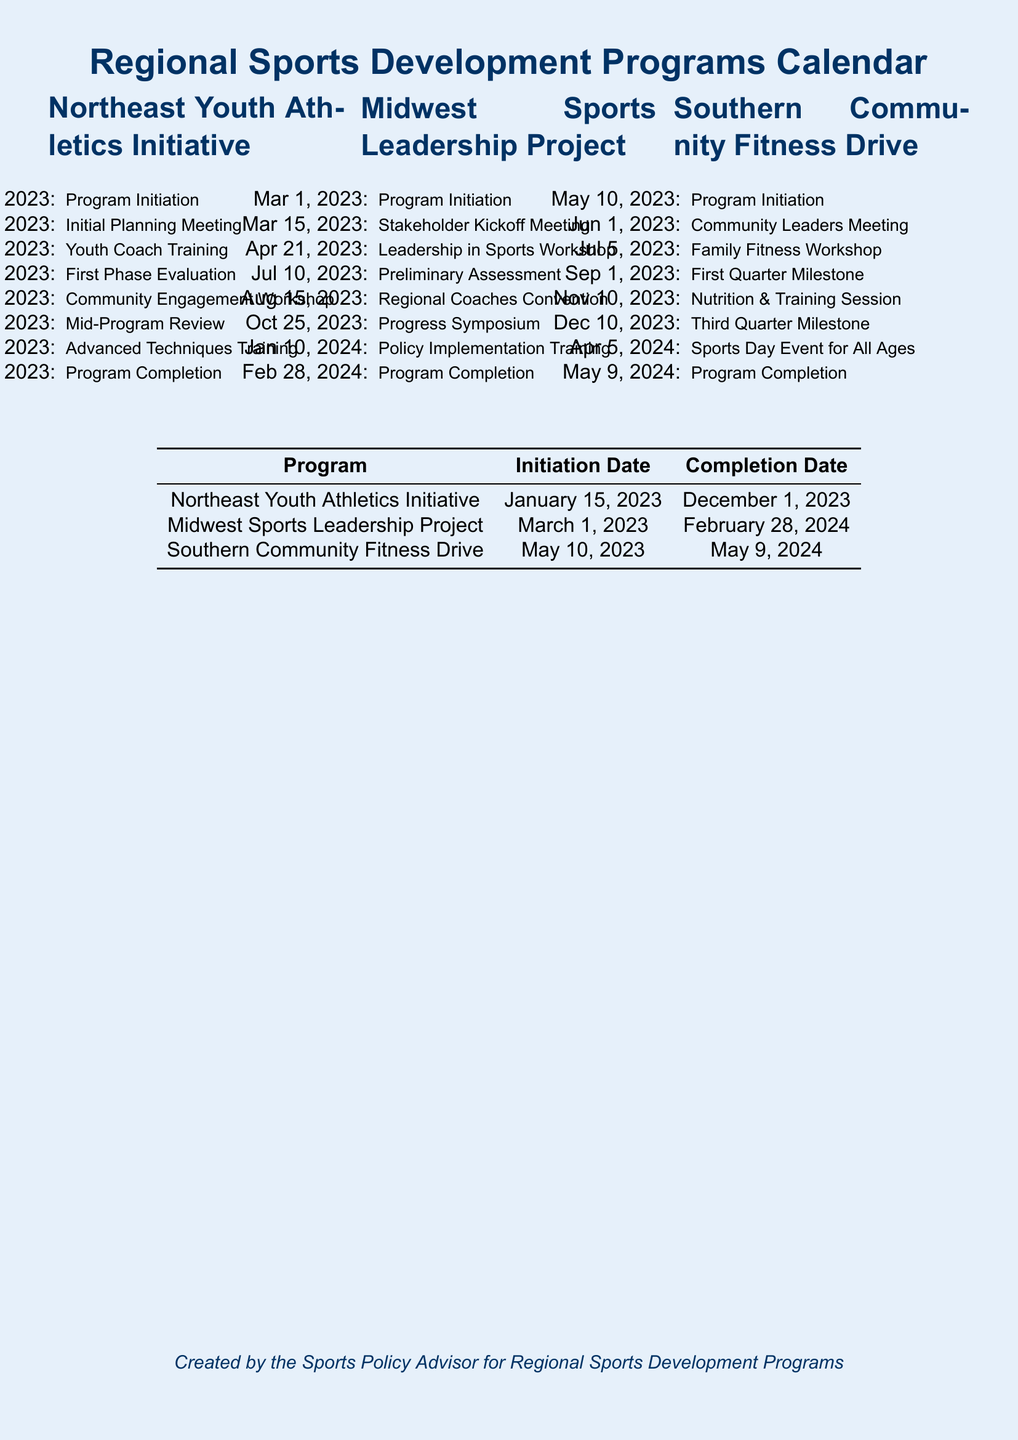What is the initiation date of the Northeast Youth Athletics Initiative? The initiation date is the first date listed for the Northeast Youth Athletics Initiative in the document, which is January 15, 2023.
Answer: January 15, 2023 When is the Program Completion for the Southern Community Fitness Drive? The Program Completion date is the last date listed for the Southern Community Fitness Drive in the document, which is May 9, 2024.
Answer: May 9, 2024 What was held on July 20, 2023, in the Northeast Youth Athletics Initiative? The event held on this date is specified in the document as a Community Engagement Workshop.
Answer: Community Engagement Workshop What is the total number of milestones in the Southern Community Fitness Drive? By counting the listed events leading to Program Completion, there are four milestones detailed in the document.
Answer: Four What training session happens right before the Program Completion of the Midwest Sports Leadership Project? The training session listed just before the completion date is the Policy Implementation Training on January 10, 2024.
Answer: Policy Implementation Training What significant meeting occurs on March 15, 2023, for the Midwest Sports Leadership Project? The document states that a Stakeholder Kickoff Meeting is scheduled on this date.
Answer: Stakeholder Kickoff Meeting What is the main purpose of the events outlined in the document? The events are part of regional sports development programs aimed at enhancing community engagement and sports leadership.
Answer: Sports development Which initiative has the earliest start date? The Northeast Youth Athletics Initiative starts on January 15, 2023, making it the earliest among the programs listed.
Answer: Northeast Youth Athletics Initiative 